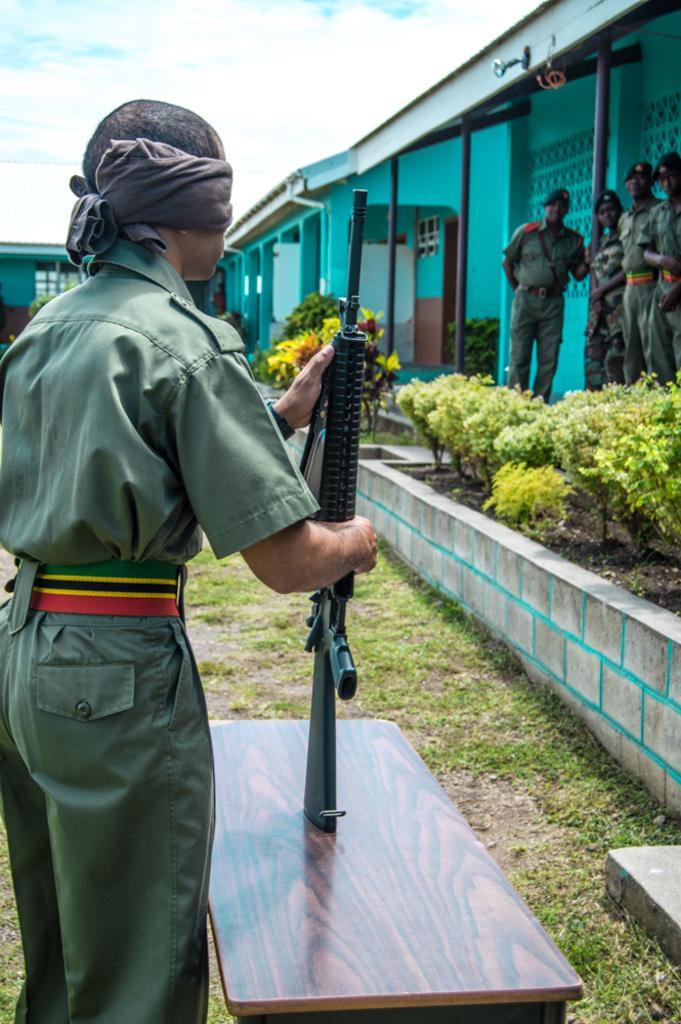Describe this image in one or two sentences. In this image I can see the person wearing the uniform which is in green color. I can see the person holding the weapon and it is on the table. I can see the person is having the cloth to the eyes. To the side of the person I can see many plants. In the background I can see the house, few more people with uniforms, clouds and the sky. 